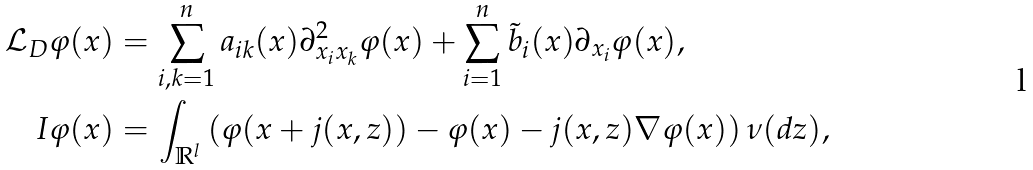Convert formula to latex. <formula><loc_0><loc_0><loc_500><loc_500>\mathcal { L } _ { D } \varphi ( x ) & = \sum _ { i , k = 1 } ^ { n } a _ { i k } ( x ) \partial ^ { 2 } _ { x _ { i } x _ { k } } \varphi ( x ) + \sum _ { i = 1 } ^ { n } \tilde { b } _ { i } ( x ) \partial _ { x _ { i } } \varphi ( x ) , \\ I \varphi ( x ) & = \int _ { \mathbb { R } ^ { l } } \left ( \varphi ( x + j ( x , z ) ) - \varphi ( x ) - j ( x , z ) \nabla \varphi ( x ) \right ) \nu ( d z ) ,</formula> 